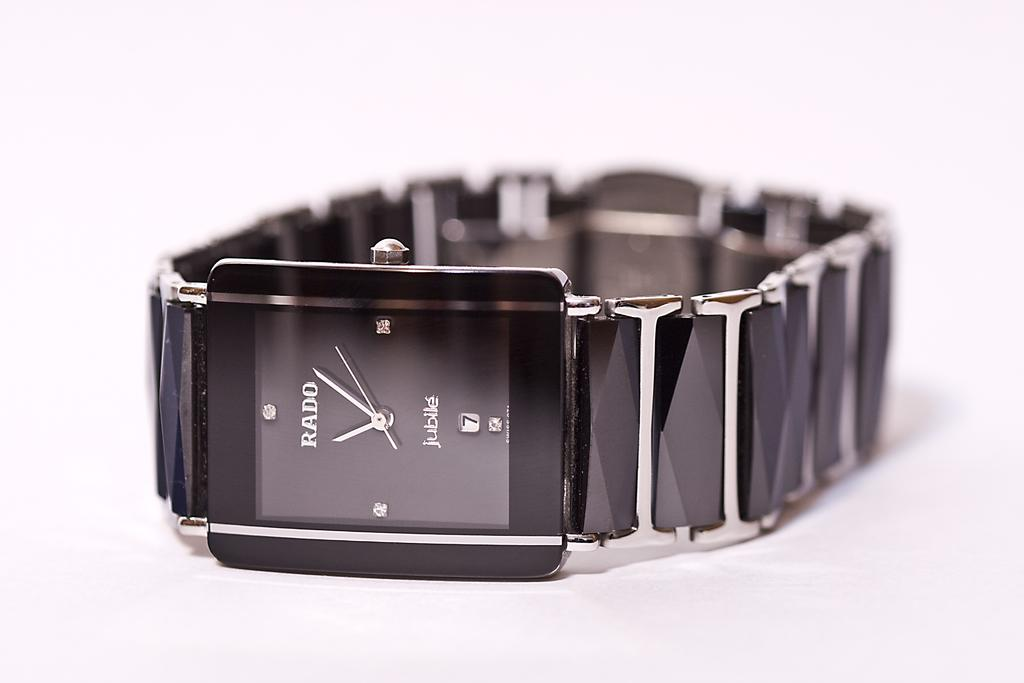<image>
Present a compact description of the photo's key features. A black rado jubile watch with diamonds in the face. 